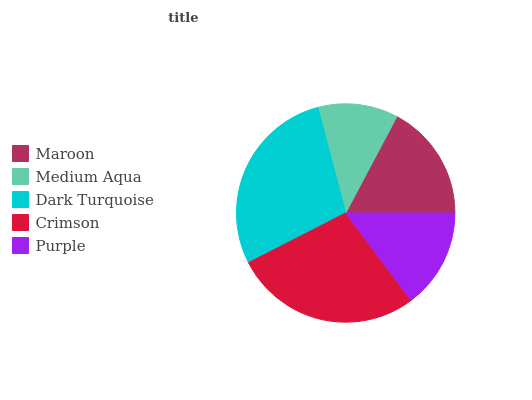Is Medium Aqua the minimum?
Answer yes or no. Yes. Is Dark Turquoise the maximum?
Answer yes or no. Yes. Is Dark Turquoise the minimum?
Answer yes or no. No. Is Medium Aqua the maximum?
Answer yes or no. No. Is Dark Turquoise greater than Medium Aqua?
Answer yes or no. Yes. Is Medium Aqua less than Dark Turquoise?
Answer yes or no. Yes. Is Medium Aqua greater than Dark Turquoise?
Answer yes or no. No. Is Dark Turquoise less than Medium Aqua?
Answer yes or no. No. Is Maroon the high median?
Answer yes or no. Yes. Is Maroon the low median?
Answer yes or no. Yes. Is Purple the high median?
Answer yes or no. No. Is Medium Aqua the low median?
Answer yes or no. No. 